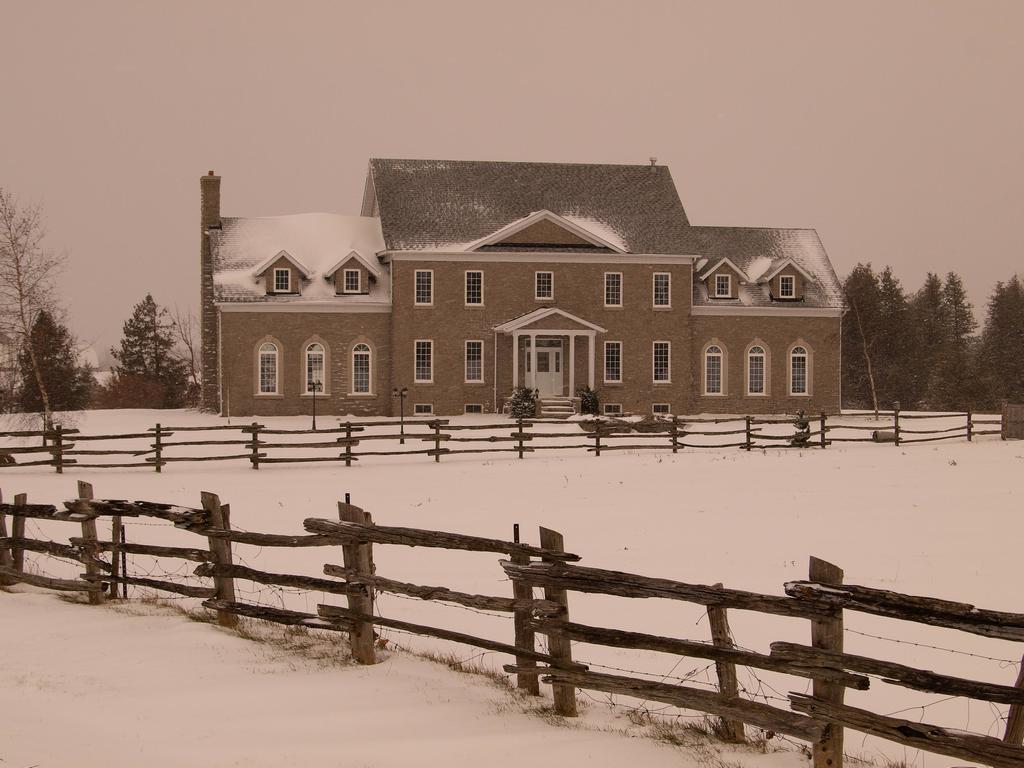Could you give a brief overview of what you see in this image? In this image, I can see a house and the snow. In front of the house, there are plants and wooden fences. On the left and right side of the image, I can see the trees. In the background there is the sky. 